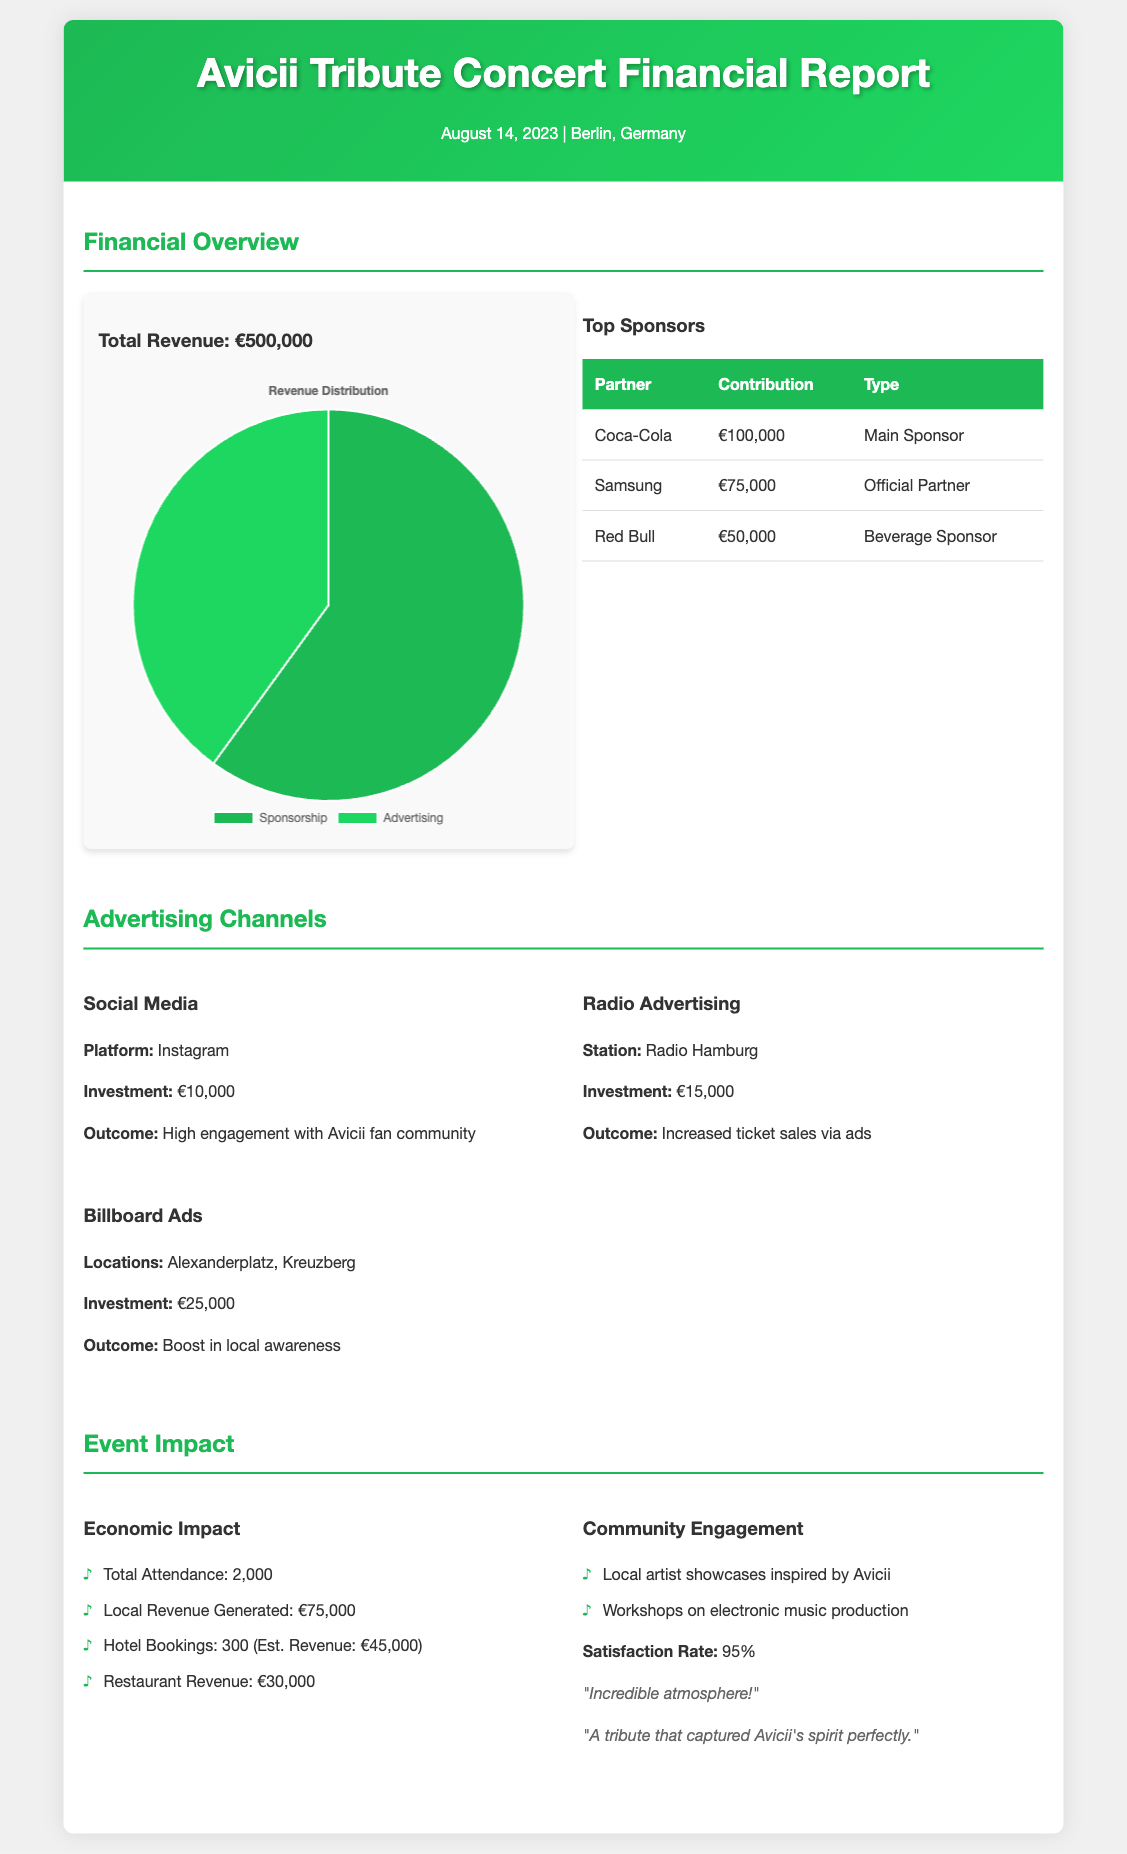What is the total revenue? The total revenue is listed in the financial overview section of the document as €500,000.
Answer: €500,000 Who was the main sponsor? The document identifies Coca-Cola as the main sponsor with a contribution of €100,000.
Answer: Coca-Cola How much was invested in billboard ads? The investment for billboard ads is detailed in the advertising channels section as €25,000.
Answer: €25,000 What was the local revenue generated? The economic impact section states that local revenue generated from the event was €75,000.
Answer: €75,000 What is the satisfaction rate? The satisfaction rate is mentioned in the community engagement section of the document as 95%.
Answer: 95% Which city hosted the Avicii Tribute Concert? The location of the concert is noted in the header of the document, which is Berlin, Germany.
Answer: Berlin How many tickets were sold for the event? The total attendance, which reflects ticket sales, is recorded in the economic impact section as 2,000.
Answer: 2,000 What type of sponsorship did Red Bull provide? The contribution type of Red Bull is noted in the top sponsors table as Beverage Sponsor.
Answer: Beverage Sponsor What was the investment in social media advertising? The investment for social media advertising is specified in the advertising channels section as €10,000.
Answer: €10,000 